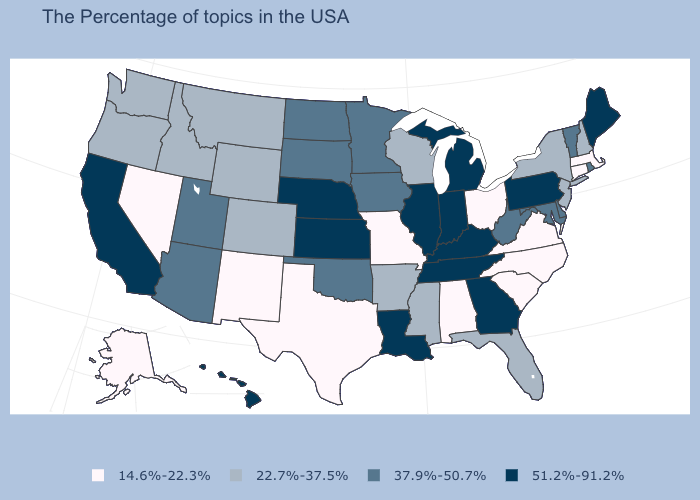What is the lowest value in the West?
Answer briefly. 14.6%-22.3%. What is the value of Hawaii?
Answer briefly. 51.2%-91.2%. What is the lowest value in states that border New Jersey?
Answer briefly. 22.7%-37.5%. Does the map have missing data?
Give a very brief answer. No. What is the value of Idaho?
Be succinct. 22.7%-37.5%. Does the first symbol in the legend represent the smallest category?
Answer briefly. Yes. Which states hav the highest value in the Northeast?
Be succinct. Maine, Pennsylvania. Name the states that have a value in the range 37.9%-50.7%?
Keep it brief. Rhode Island, Vermont, Delaware, Maryland, West Virginia, Minnesota, Iowa, Oklahoma, South Dakota, North Dakota, Utah, Arizona. Does Iowa have a higher value than California?
Be succinct. No. Does Delaware have the highest value in the South?
Quick response, please. No. Which states hav the highest value in the Northeast?
Give a very brief answer. Maine, Pennsylvania. Among the states that border Delaware , does New Jersey have the lowest value?
Short answer required. Yes. Does Kentucky have a higher value than Georgia?
Quick response, please. No. Name the states that have a value in the range 37.9%-50.7%?
Write a very short answer. Rhode Island, Vermont, Delaware, Maryland, West Virginia, Minnesota, Iowa, Oklahoma, South Dakota, North Dakota, Utah, Arizona. Does Hawaii have the highest value in the West?
Short answer required. Yes. 